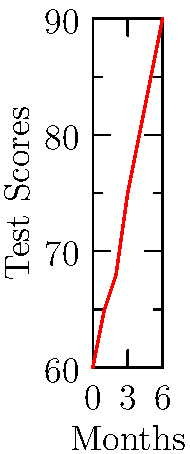The line graph shows the academic progress of a foster child over a 6-month period. If the trend continues, what would be the expected test score at the end of the 8th month? To solve this problem, we need to follow these steps:

1. Observe the trend in the graph:
   The line shows a steady increase in test scores over time.

2. Calculate the rate of change:
   - Initial score (month 0): 60
   - Final score (month 6): 90
   - Total change: $90 - 60 = 30$ points
   - Time period: 6 months
   - Rate of change: $\frac{30}{6} = 5$ points per month

3. Extend the trend:
   - We need to predict 2 months beyond the given data (from month 6 to month 8)
   - Additional increase: $5 \text{ points/month} \times 2 \text{ months} = 10 \text{ points}$

4. Calculate the predicted score:
   - Final score at month 6: 90
   - Predicted score at month 8: $90 + 10 = 100$

Therefore, if the trend continues, the expected test score at the end of the 8th month would be 100.
Answer: 100 